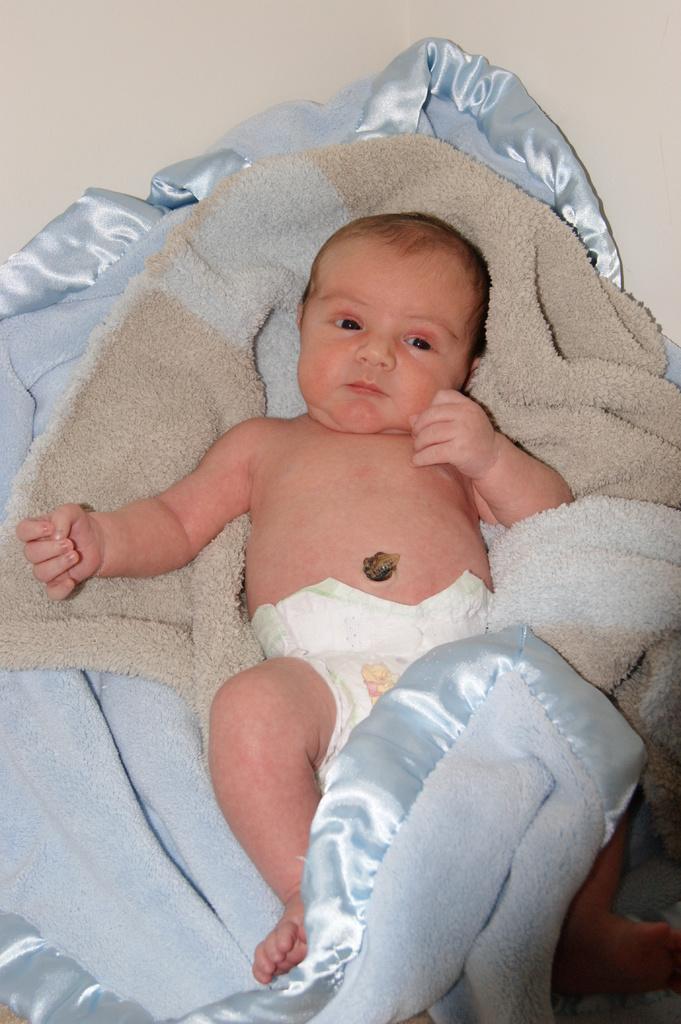Please provide a concise description of this image. In this image I can see a baby is laying on a bed sheet. At the top there is a wall. 